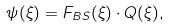Convert formula to latex. <formula><loc_0><loc_0><loc_500><loc_500>\psi ( \xi ) = F _ { B S } ( \xi ) \cdot Q ( \xi ) ,</formula> 